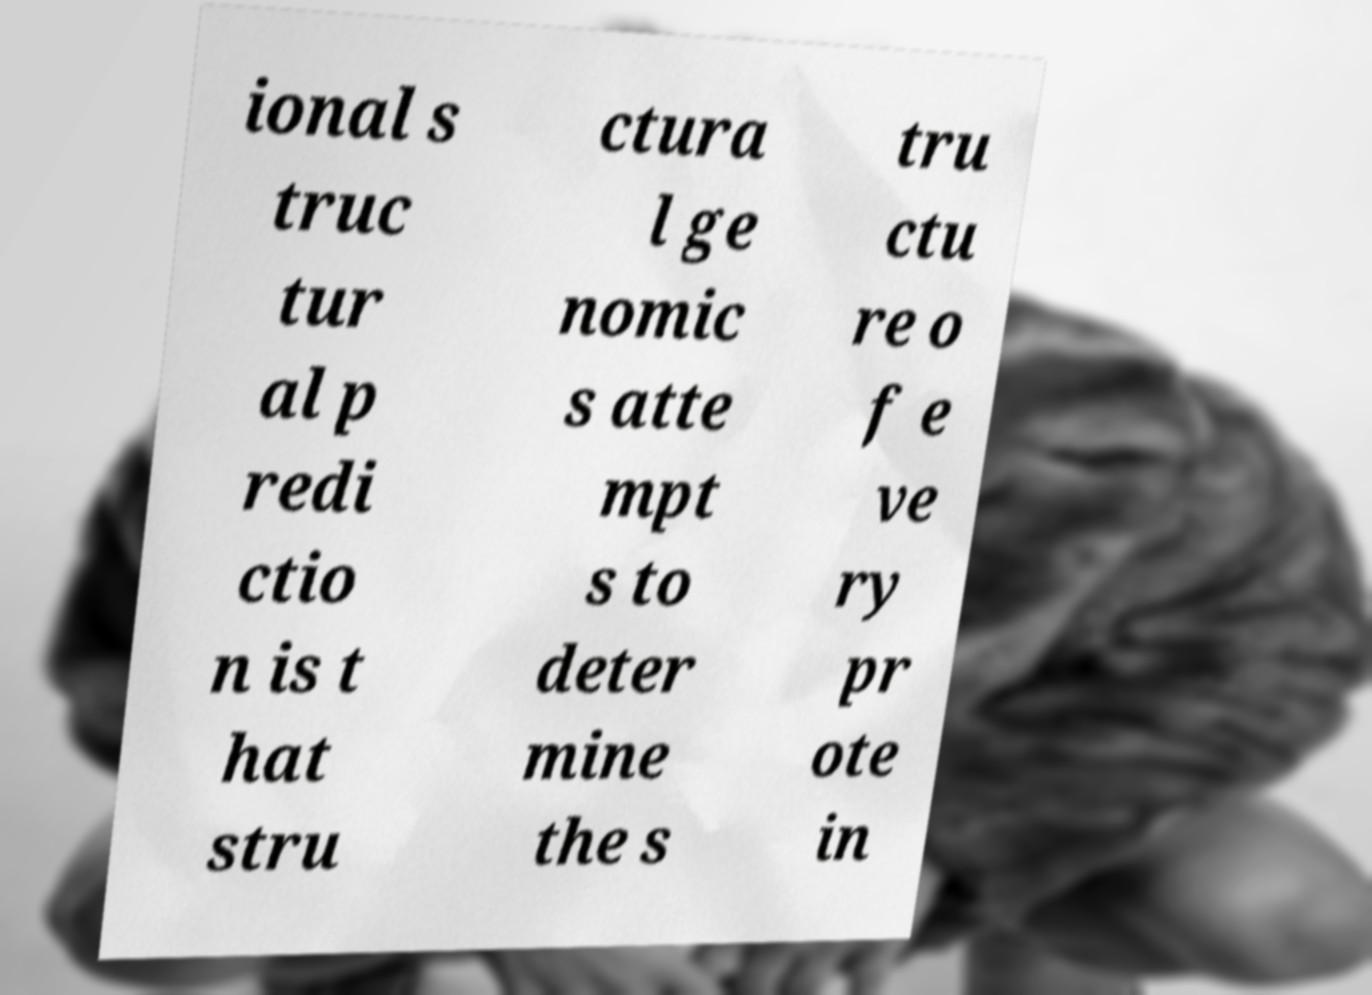Could you assist in decoding the text presented in this image and type it out clearly? ional s truc tur al p redi ctio n is t hat stru ctura l ge nomic s atte mpt s to deter mine the s tru ctu re o f e ve ry pr ote in 